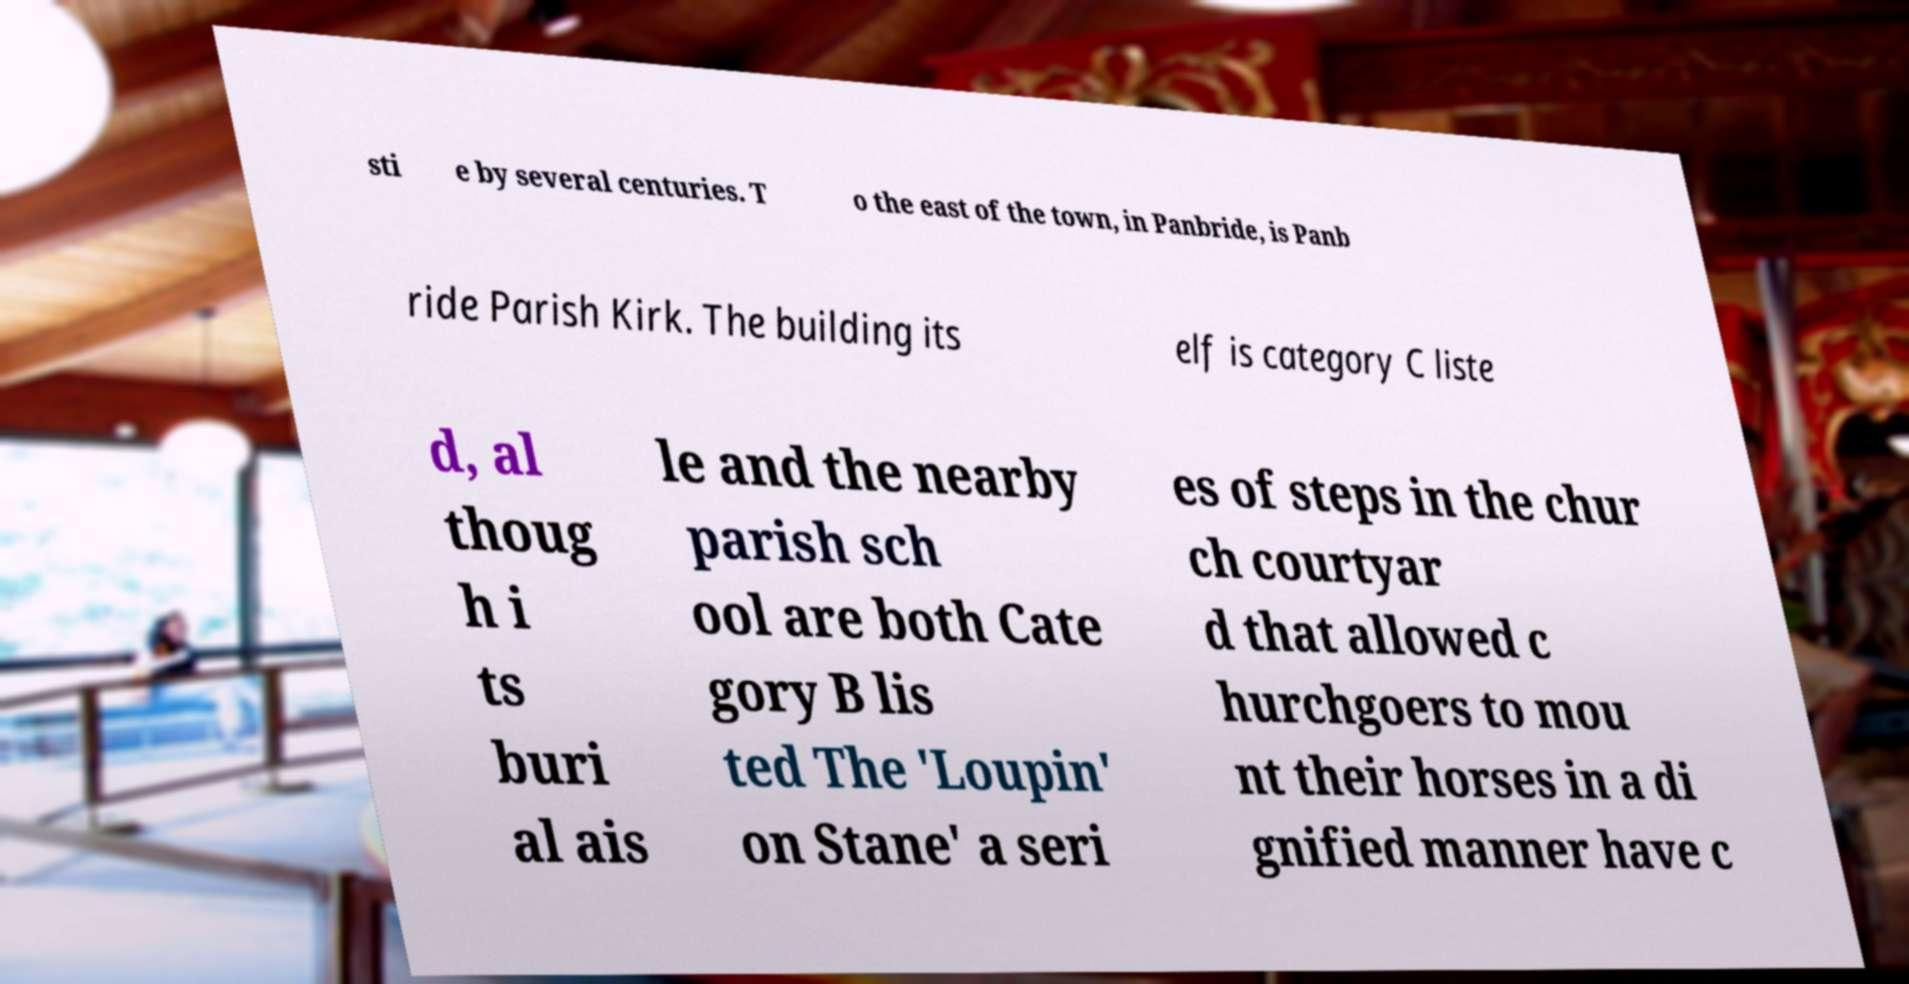Please identify and transcribe the text found in this image. sti e by several centuries. T o the east of the town, in Panbride, is Panb ride Parish Kirk. The building its elf is category C liste d, al thoug h i ts buri al ais le and the nearby parish sch ool are both Cate gory B lis ted The 'Loupin' on Stane' a seri es of steps in the chur ch courtyar d that allowed c hurchgoers to mou nt their horses in a di gnified manner have c 